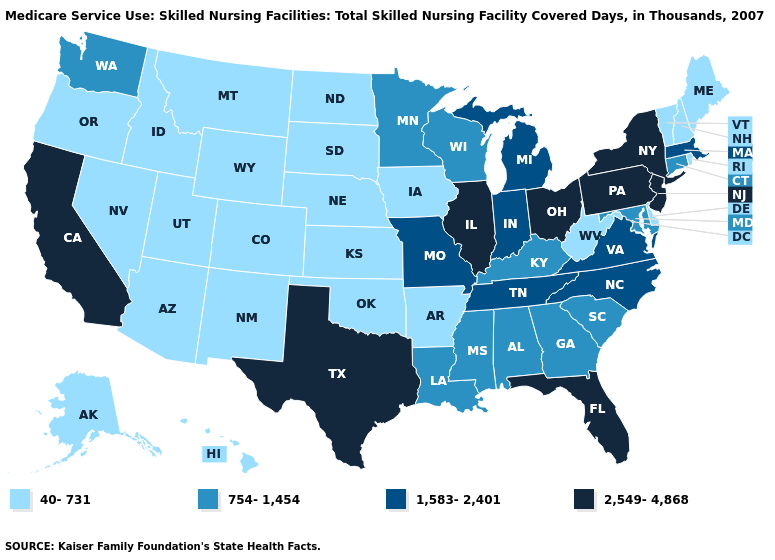What is the value of Maine?
Quick response, please. 40-731. Among the states that border Minnesota , which have the highest value?
Concise answer only. Wisconsin. Which states have the lowest value in the USA?
Answer briefly. Alaska, Arizona, Arkansas, Colorado, Delaware, Hawaii, Idaho, Iowa, Kansas, Maine, Montana, Nebraska, Nevada, New Hampshire, New Mexico, North Dakota, Oklahoma, Oregon, Rhode Island, South Dakota, Utah, Vermont, West Virginia, Wyoming. Does Michigan have the lowest value in the USA?
Give a very brief answer. No. What is the highest value in states that border Delaware?
Keep it brief. 2,549-4,868. What is the lowest value in the USA?
Quick response, please. 40-731. What is the lowest value in the USA?
Concise answer only. 40-731. Among the states that border Kentucky , does Missouri have the lowest value?
Give a very brief answer. No. What is the highest value in the USA?
Keep it brief. 2,549-4,868. Name the states that have a value in the range 1,583-2,401?
Give a very brief answer. Indiana, Massachusetts, Michigan, Missouri, North Carolina, Tennessee, Virginia. What is the highest value in the USA?
Keep it brief. 2,549-4,868. What is the value of Nevada?
Write a very short answer. 40-731. What is the value of Wyoming?
Concise answer only. 40-731. Name the states that have a value in the range 1,583-2,401?
Be succinct. Indiana, Massachusetts, Michigan, Missouri, North Carolina, Tennessee, Virginia. Which states have the lowest value in the USA?
Concise answer only. Alaska, Arizona, Arkansas, Colorado, Delaware, Hawaii, Idaho, Iowa, Kansas, Maine, Montana, Nebraska, Nevada, New Hampshire, New Mexico, North Dakota, Oklahoma, Oregon, Rhode Island, South Dakota, Utah, Vermont, West Virginia, Wyoming. 